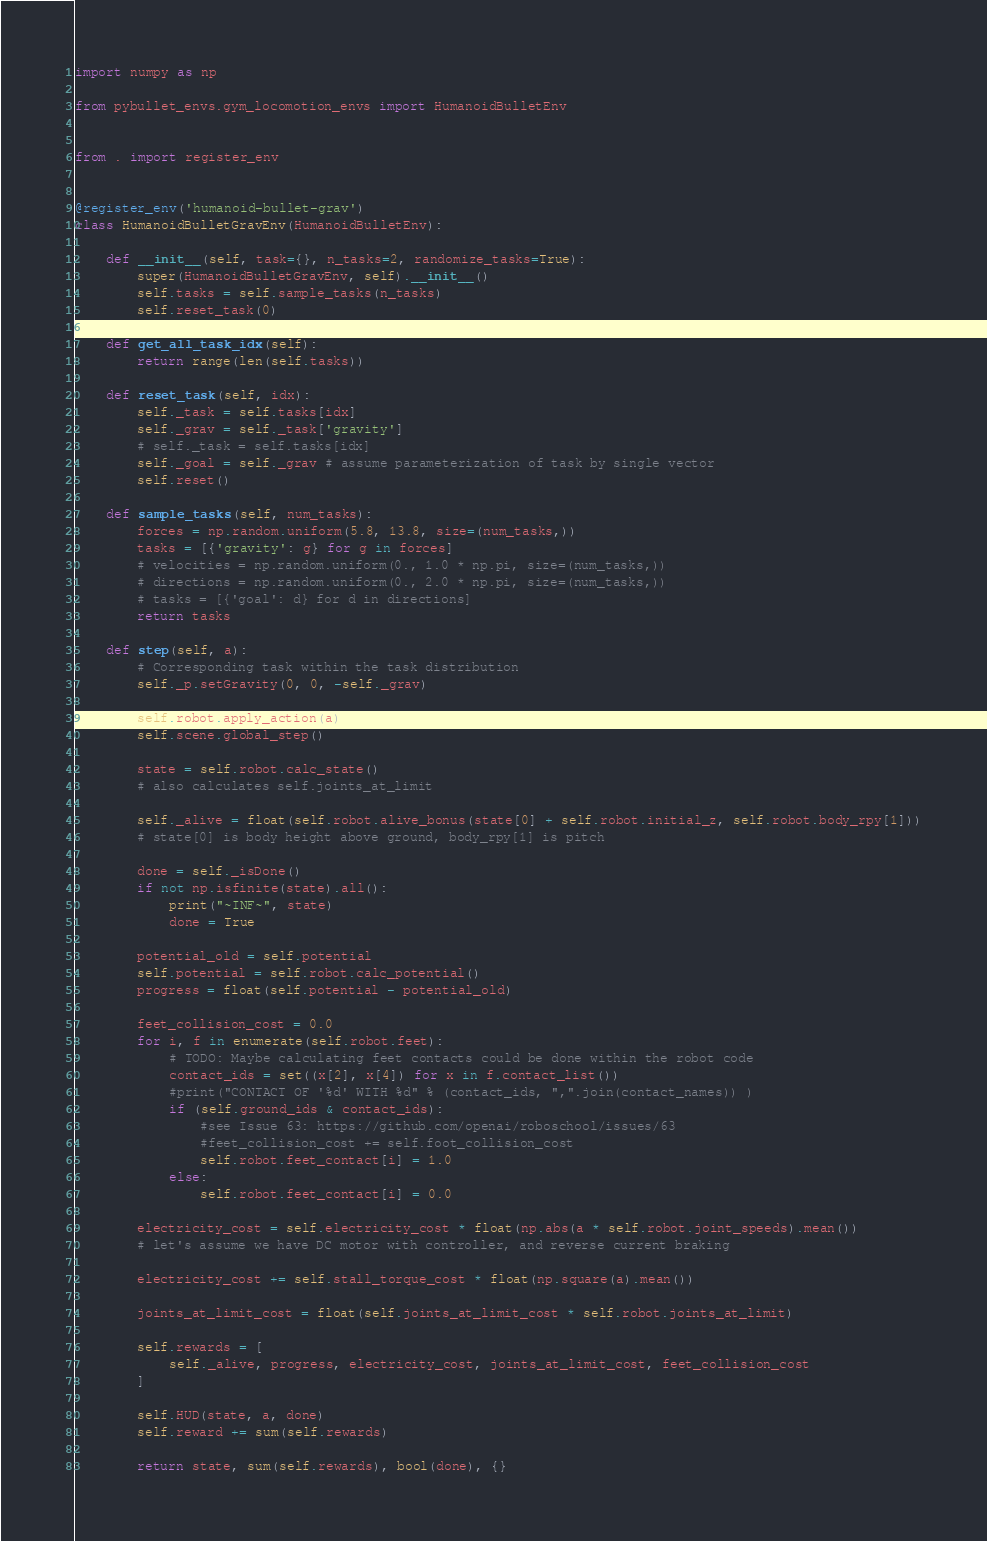Convert code to text. <code><loc_0><loc_0><loc_500><loc_500><_Python_>import numpy as np

from pybullet_envs.gym_locomotion_envs import HumanoidBulletEnv


from . import register_env


@register_env('humanoid-bullet-grav')
class HumanoidBulletGravEnv(HumanoidBulletEnv):

    def __init__(self, task={}, n_tasks=2, randomize_tasks=True):
        super(HumanoidBulletGravEnv, self).__init__()
        self.tasks = self.sample_tasks(n_tasks)
        self.reset_task(0)

    def get_all_task_idx(self):
        return range(len(self.tasks))

    def reset_task(self, idx):
        self._task = self.tasks[idx]
        self._grav = self._task['gravity']
        # self._task = self.tasks[idx]
        self._goal = self._grav # assume parameterization of task by single vector
        self.reset()

    def sample_tasks(self, num_tasks):
        forces = np.random.uniform(5.8, 13.8, size=(num_tasks,))
        tasks = [{'gravity': g} for g in forces]
        # velocities = np.random.uniform(0., 1.0 * np.pi, size=(num_tasks,))
        # directions = np.random.uniform(0., 2.0 * np.pi, size=(num_tasks,))
        # tasks = [{'goal': d} for d in directions]
        return tasks

    def step(self, a):
        # Corresponding task within the task distribution
        self._p.setGravity(0, 0, -self._grav)

        self.robot.apply_action(a)
        self.scene.global_step()

        state = self.robot.calc_state()
        # also calculates self.joints_at_limit

        self._alive = float(self.robot.alive_bonus(state[0] + self.robot.initial_z, self.robot.body_rpy[1]))
        # state[0] is body height above ground, body_rpy[1] is pitch

        done = self._isDone()
        if not np.isfinite(state).all():
            print("~INF~", state)
            done = True

        potential_old = self.potential
        self.potential = self.robot.calc_potential()
        progress = float(self.potential - potential_old)

        feet_collision_cost = 0.0
        for i, f in enumerate(self.robot.feet):
            # TODO: Maybe calculating feet contacts could be done within the robot code
            contact_ids = set((x[2], x[4]) for x in f.contact_list())
            #print("CONTACT OF '%d' WITH %d" % (contact_ids, ",".join(contact_names)) )
            if (self.ground_ids & contact_ids):
                #see Issue 63: https://github.com/openai/roboschool/issues/63
                #feet_collision_cost += self.foot_collision_cost
                self.robot.feet_contact[i] = 1.0
            else:
                self.robot.feet_contact[i] = 0.0

        electricity_cost = self.electricity_cost * float(np.abs(a * self.robot.joint_speeds).mean())
        # let's assume we have DC motor with controller, and reverse current braking

        electricity_cost += self.stall_torque_cost * float(np.square(a).mean())

        joints_at_limit_cost = float(self.joints_at_limit_cost * self.robot.joints_at_limit)

        self.rewards = [
            self._alive, progress, electricity_cost, joints_at_limit_cost, feet_collision_cost
        ]

        self.HUD(state, a, done)
        self.reward += sum(self.rewards)

        return state, sum(self.rewards), bool(done), {}
</code> 